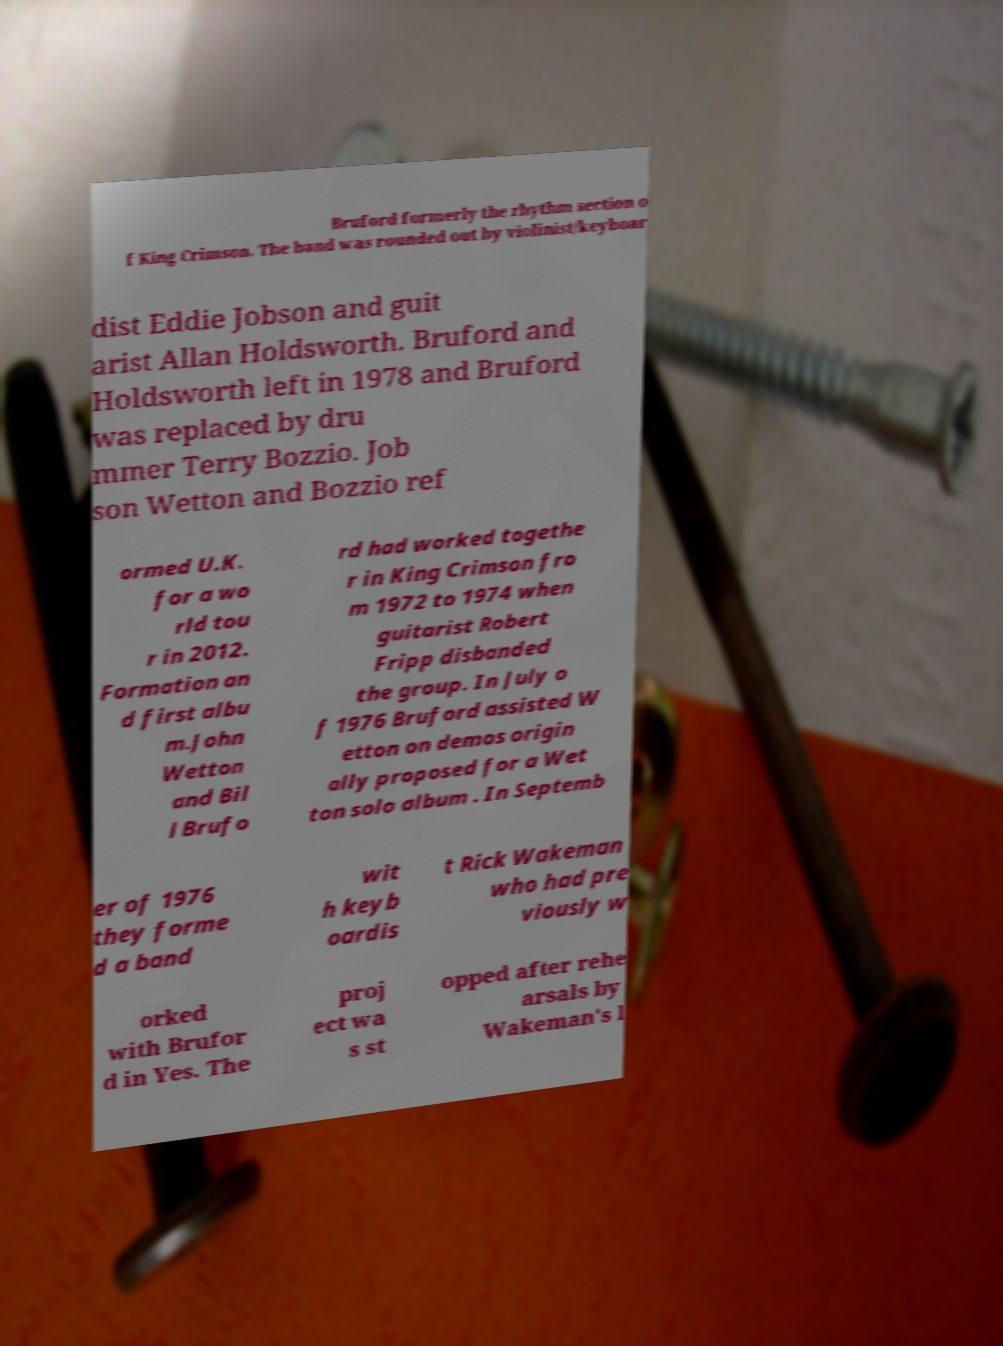Please identify and transcribe the text found in this image. Bruford formerly the rhythm section o f King Crimson. The band was rounded out by violinist/keyboar dist Eddie Jobson and guit arist Allan Holdsworth. Bruford and Holdsworth left in 1978 and Bruford was replaced by dru mmer Terry Bozzio. Job son Wetton and Bozzio ref ormed U.K. for a wo rld tou r in 2012. Formation an d first albu m.John Wetton and Bil l Brufo rd had worked togethe r in King Crimson fro m 1972 to 1974 when guitarist Robert Fripp disbanded the group. In July o f 1976 Bruford assisted W etton on demos origin ally proposed for a Wet ton solo album . In Septemb er of 1976 they forme d a band wit h keyb oardis t Rick Wakeman who had pre viously w orked with Brufor d in Yes. The proj ect wa s st opped after rehe arsals by Wakeman's l 